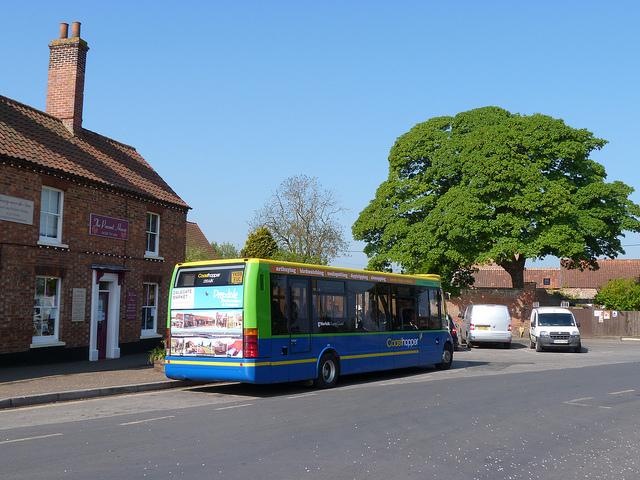What is the blue and green vehicle called?
Short answer required. Bus. Is the bus in the United States?
Give a very brief answer. No. What is the building made of?
Be succinct. Brick. 